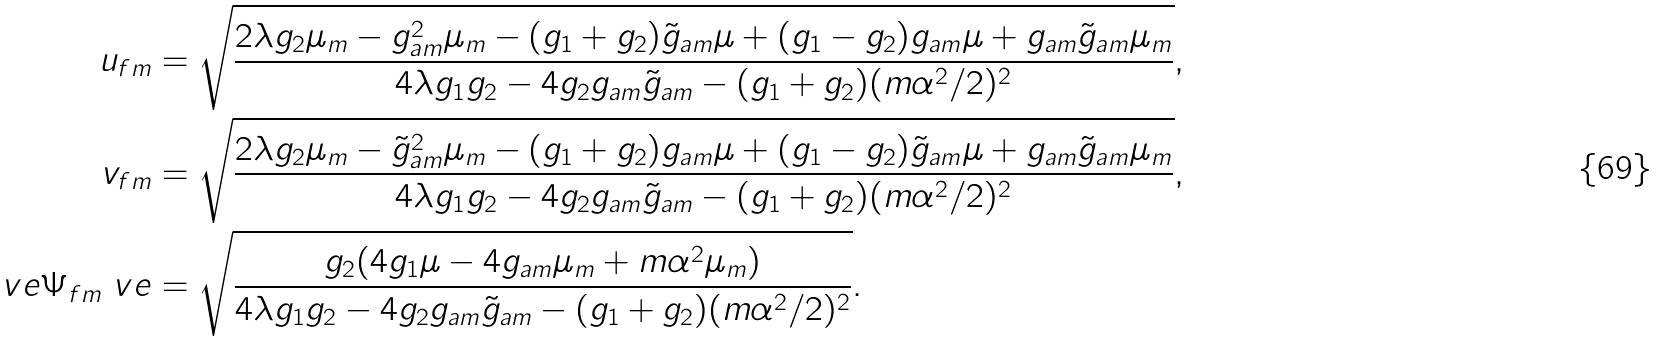Convert formula to latex. <formula><loc_0><loc_0><loc_500><loc_500>u _ { f m } & = \sqrt { \frac { 2 \lambda g _ { 2 } \mu _ { m } - g _ { a m } ^ { 2 } \mu _ { m } - ( g _ { 1 } + g _ { 2 } ) \tilde { g } _ { a m } \mu + ( g _ { 1 } - g _ { 2 } ) g _ { a m } \mu + g _ { a m } \tilde { g } _ { a m } \mu _ { m } } { 4 \lambda g _ { 1 } g _ { 2 } - 4 g _ { 2 } g _ { a m } \tilde { g } _ { a m } - ( g _ { 1 } + g _ { 2 } ) ( m \alpha ^ { 2 } / 2 ) ^ { 2 } } } , \quad \\ v _ { f m } & = \sqrt { \frac { 2 \lambda g _ { 2 } \mu _ { m } - { \tilde { g } _ { a m } } ^ { 2 } \mu _ { m } - ( g _ { 1 } + g _ { 2 } ) g _ { a m } \mu + ( g _ { 1 } - g _ { 2 } ) \tilde { g } _ { a m } \mu + g _ { a m } \tilde { g } _ { a m } \mu _ { m } } { 4 \lambda g _ { 1 } g _ { 2 } - 4 g _ { 2 } g _ { a m } \tilde { g } _ { a m } - ( g _ { 1 } + g _ { 2 } ) ( m \alpha ^ { 2 } / 2 ) ^ { 2 } } } , \quad \\ \ v e \Psi _ { f m } \ v e & = \sqrt { \frac { g _ { 2 } ( 4 g _ { 1 } \mu - 4 g _ { a m } \mu _ { m } + m \alpha ^ { 2 } \mu _ { m } ) } { 4 \lambda g _ { 1 } g _ { 2 } - 4 g _ { 2 } g _ { a m } \tilde { g } _ { a m } - ( g _ { 1 } + g _ { 2 } ) ( m \alpha ^ { 2 } / 2 ) ^ { 2 } } } .</formula> 